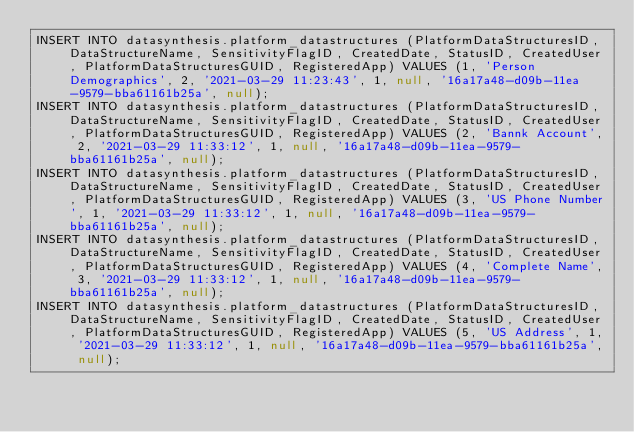Convert code to text. <code><loc_0><loc_0><loc_500><loc_500><_SQL_>INSERT INTO datasynthesis.platform_datastructures (PlatformDataStructuresID, DataStructureName, SensitivityFlagID, CreatedDate, StatusID, CreatedUser, PlatformDataStructuresGUID, RegisteredApp) VALUES (1, 'Person Demographics', 2, '2021-03-29 11:23:43', 1, null, '16a17a48-d09b-11ea-9579-bba61161b25a', null);
INSERT INTO datasynthesis.platform_datastructures (PlatformDataStructuresID, DataStructureName, SensitivityFlagID, CreatedDate, StatusID, CreatedUser, PlatformDataStructuresGUID, RegisteredApp) VALUES (2, 'Bannk Account', 2, '2021-03-29 11:33:12', 1, null, '16a17a48-d09b-11ea-9579-bba61161b25a', null);
INSERT INTO datasynthesis.platform_datastructures (PlatformDataStructuresID, DataStructureName, SensitivityFlagID, CreatedDate, StatusID, CreatedUser, PlatformDataStructuresGUID, RegisteredApp) VALUES (3, 'US Phone Number', 1, '2021-03-29 11:33:12', 1, null, '16a17a48-d09b-11ea-9579-bba61161b25a', null);
INSERT INTO datasynthesis.platform_datastructures (PlatformDataStructuresID, DataStructureName, SensitivityFlagID, CreatedDate, StatusID, CreatedUser, PlatformDataStructuresGUID, RegisteredApp) VALUES (4, 'Complete Name', 3, '2021-03-29 11:33:12', 1, null, '16a17a48-d09b-11ea-9579-bba61161b25a', null);
INSERT INTO datasynthesis.platform_datastructures (PlatformDataStructuresID, DataStructureName, SensitivityFlagID, CreatedDate, StatusID, CreatedUser, PlatformDataStructuresGUID, RegisteredApp) VALUES (5, 'US Address', 1, '2021-03-29 11:33:12', 1, null, '16a17a48-d09b-11ea-9579-bba61161b25a', null);</code> 